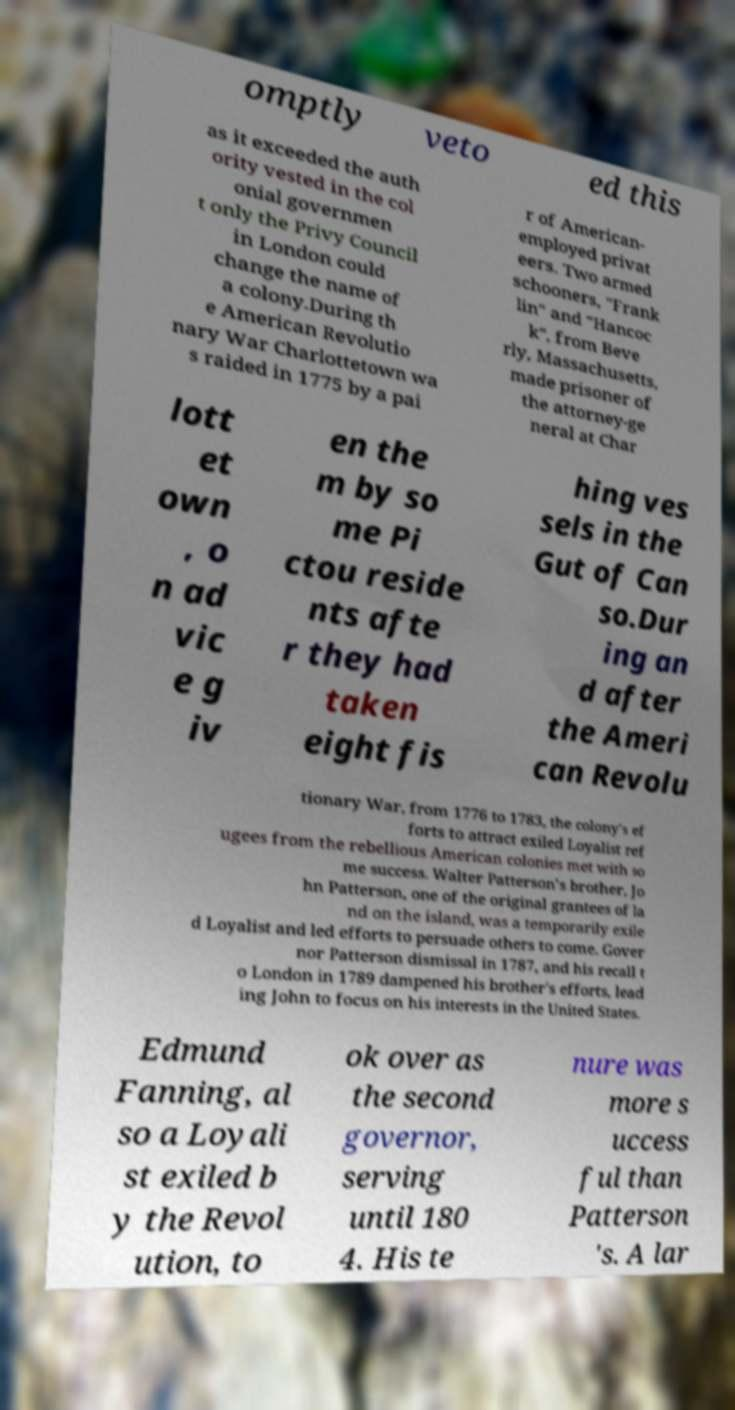There's text embedded in this image that I need extracted. Can you transcribe it verbatim? omptly veto ed this as it exceeded the auth ority vested in the col onial governmen t only the Privy Council in London could change the name of a colony.During th e American Revolutio nary War Charlottetown wa s raided in 1775 by a pai r of American- employed privat eers. Two armed schooners, "Frank lin" and "Hancoc k", from Beve rly, Massachusetts, made prisoner of the attorney-ge neral at Char lott et own , o n ad vic e g iv en the m by so me Pi ctou reside nts afte r they had taken eight fis hing ves sels in the Gut of Can so.Dur ing an d after the Ameri can Revolu tionary War, from 1776 to 1783, the colony's ef forts to attract exiled Loyalist ref ugees from the rebellious American colonies met with so me success. Walter Patterson's brother, Jo hn Patterson, one of the original grantees of la nd on the island, was a temporarily exile d Loyalist and led efforts to persuade others to come. Gover nor Patterson dismissal in 1787, and his recall t o London in 1789 dampened his brother's efforts, lead ing John to focus on his interests in the United States. Edmund Fanning, al so a Loyali st exiled b y the Revol ution, to ok over as the second governor, serving until 180 4. His te nure was more s uccess ful than Patterson 's. A lar 